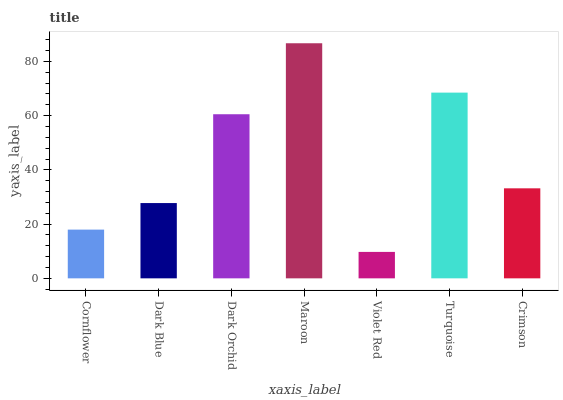Is Violet Red the minimum?
Answer yes or no. Yes. Is Maroon the maximum?
Answer yes or no. Yes. Is Dark Blue the minimum?
Answer yes or no. No. Is Dark Blue the maximum?
Answer yes or no. No. Is Dark Blue greater than Cornflower?
Answer yes or no. Yes. Is Cornflower less than Dark Blue?
Answer yes or no. Yes. Is Cornflower greater than Dark Blue?
Answer yes or no. No. Is Dark Blue less than Cornflower?
Answer yes or no. No. Is Crimson the high median?
Answer yes or no. Yes. Is Crimson the low median?
Answer yes or no. Yes. Is Turquoise the high median?
Answer yes or no. No. Is Cornflower the low median?
Answer yes or no. No. 